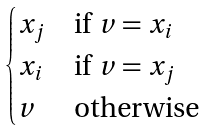<formula> <loc_0><loc_0><loc_500><loc_500>\begin{cases} x _ { j } & \text {if $v=x_{i}$} \\ x _ { i } & \text {if $v=x_{j}$} \\ v & \text {otherwise} \end{cases}</formula> 